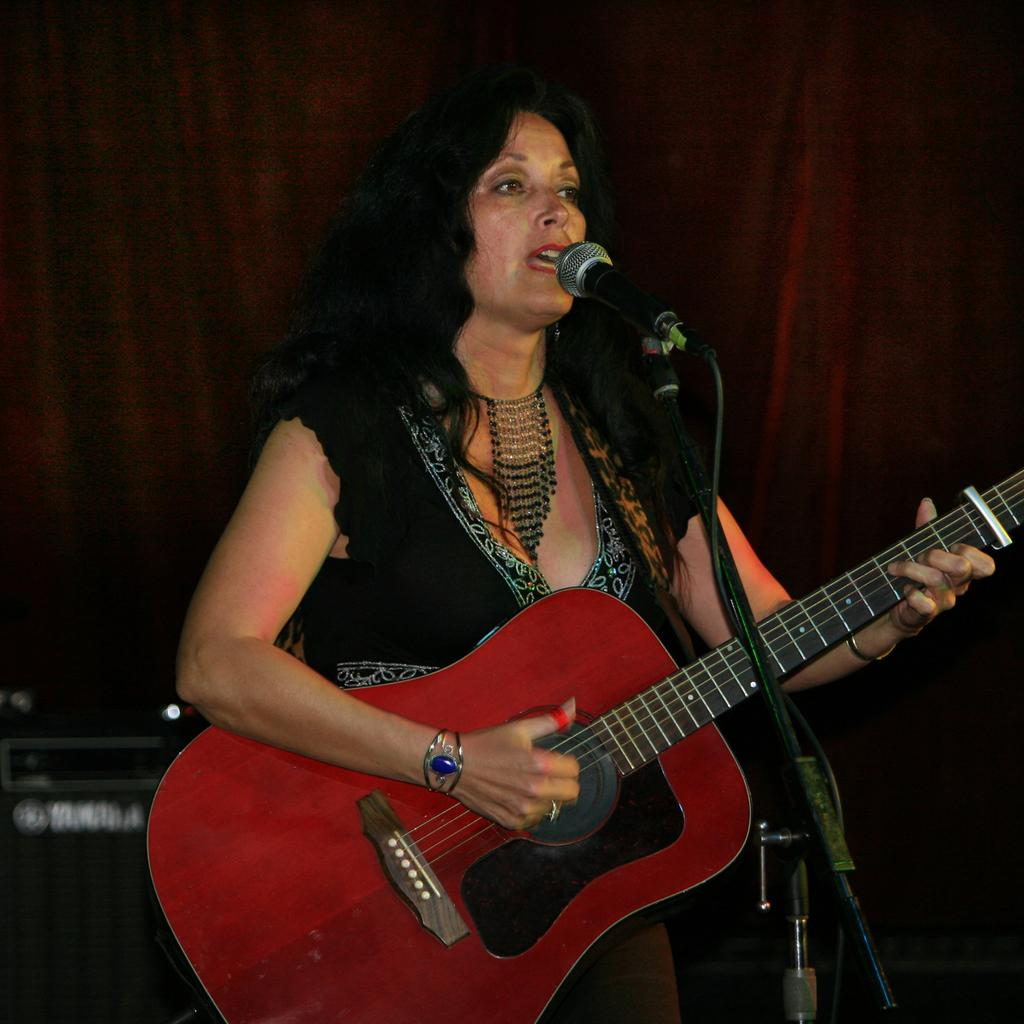What is the main subject of the image? The main subject of the image is a woman. What is the woman doing in the image? The woman is playing the guitar and standing in front of a mic. What is the woman holding in her hand? The woman is holding a guitar in her hand. What can be seen behind the woman in the image? There is a red color curtain in the background of the image. How many minutes does the woman spend planting crops in the image? There is no mention of the woman planting crops or any reference to time in the image. 